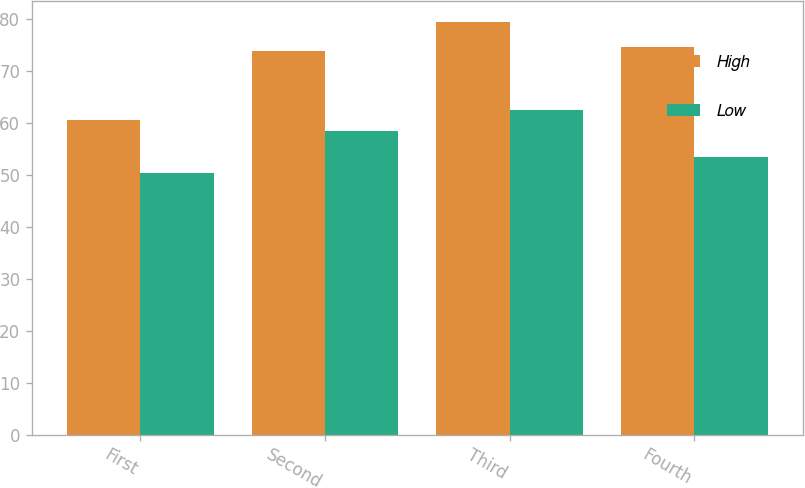Convert chart to OTSL. <chart><loc_0><loc_0><loc_500><loc_500><stacked_bar_chart><ecel><fcel>First<fcel>Second<fcel>Third<fcel>Fourth<nl><fcel>High<fcel>60.67<fcel>73.96<fcel>79.47<fcel>74.67<nl><fcel>Low<fcel>50.35<fcel>58.52<fcel>62.61<fcel>53.49<nl></chart> 